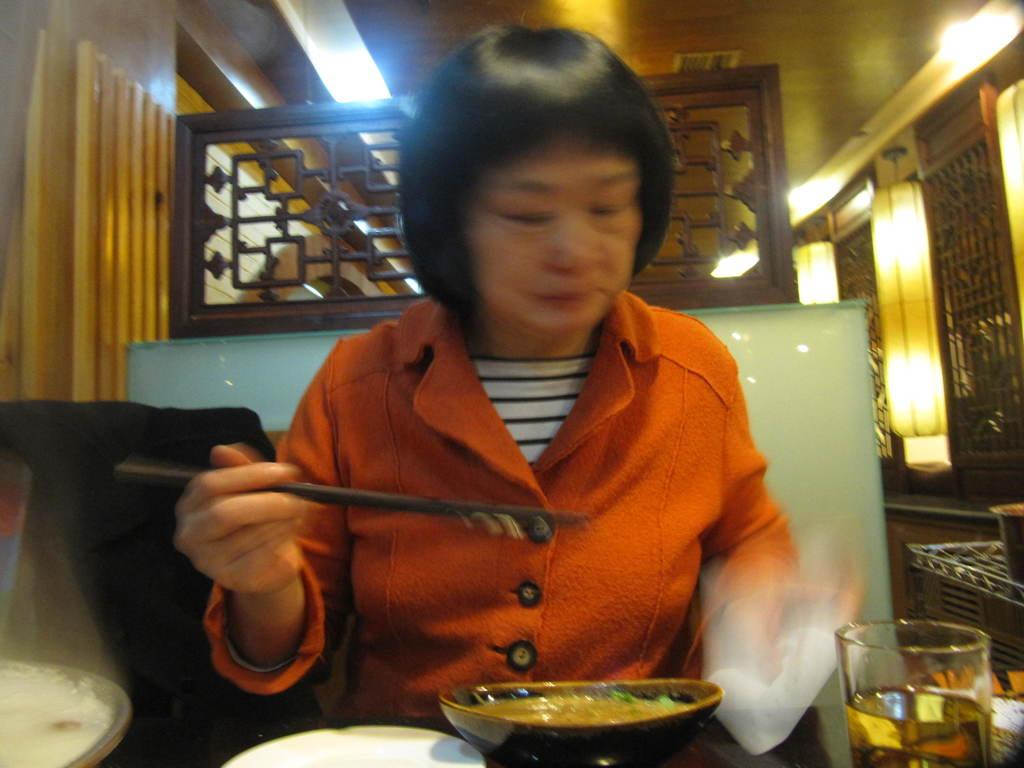Who is present in the image? There is a lady in the image. What is the lady holding in the image? The lady is holding chopsticks. What can be seen in front of the lady? There are food items in bowls in front of the lady. What is the lady possibly using to drink in the image? There is a glass of drink in the image. What can be seen on the walls in the image? The walls are visible in the image. What is providing illumination in the image? Lights are present in the image. What type of architectural feature is visible in the image? A grille is visible in the image. What news is the lady reading in the image? There is no news or any reading material visible in the image. 